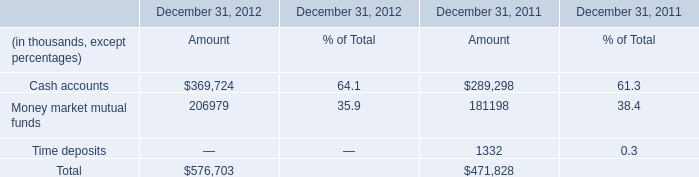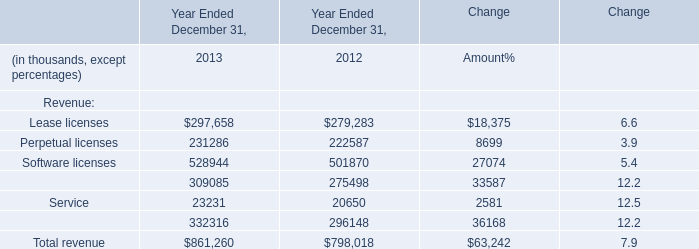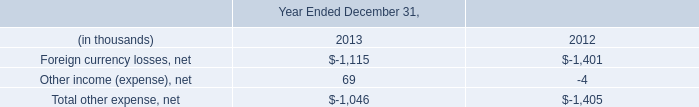What's the sum of Total revenue in 2013? (in thousand) 
Answer: 861,260. 